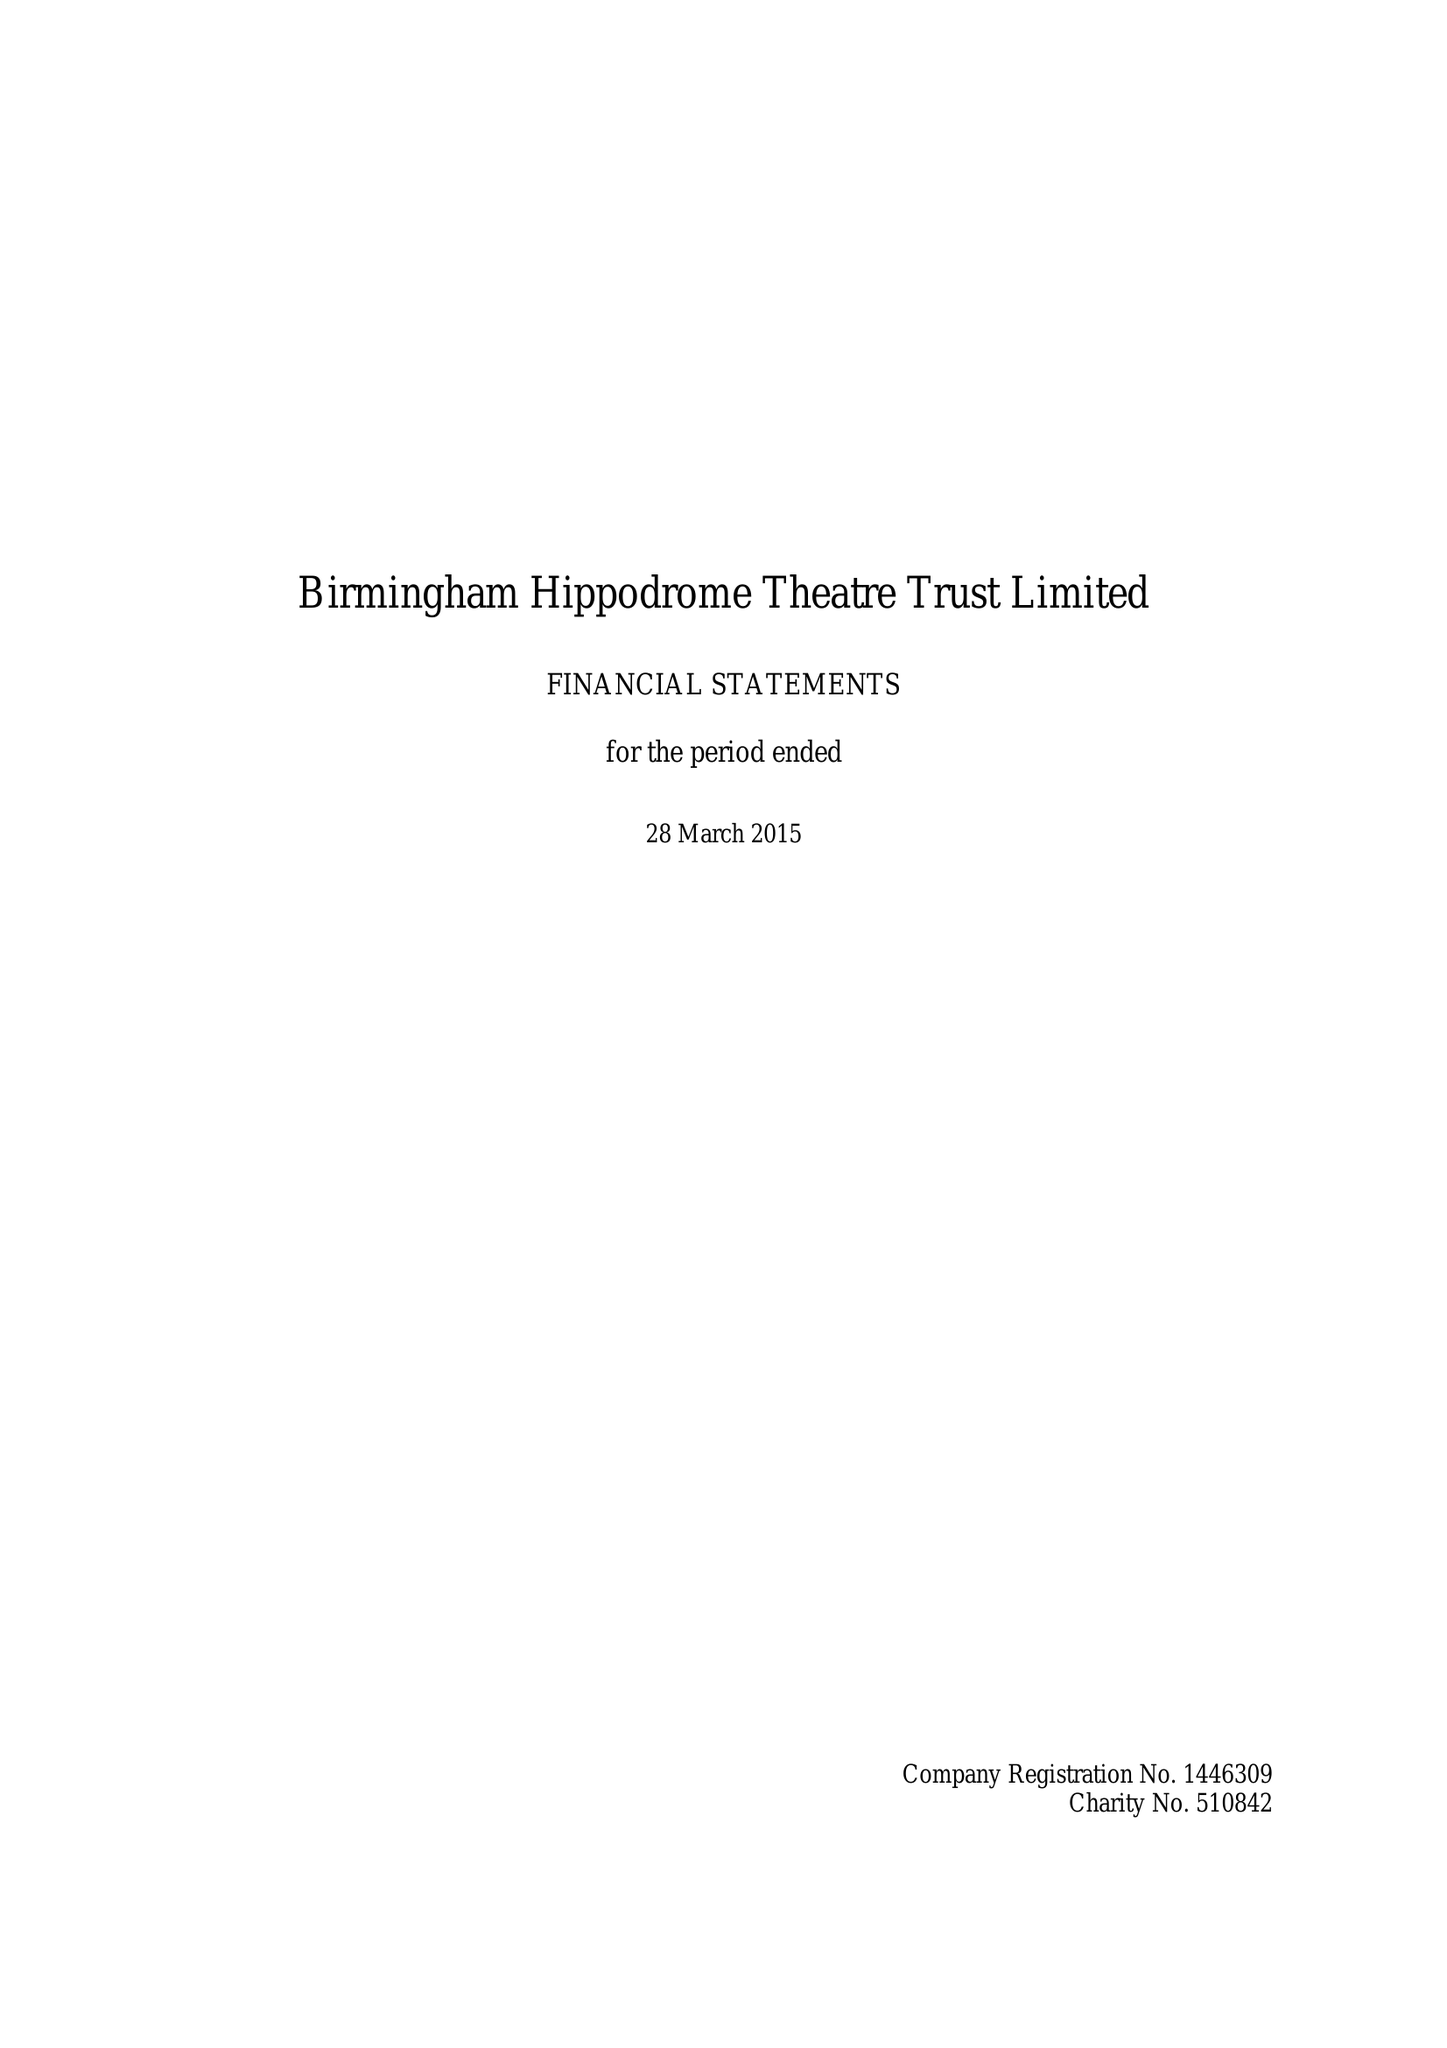What is the value for the income_annually_in_british_pounds?
Answer the question using a single word or phrase. 23321000.00 